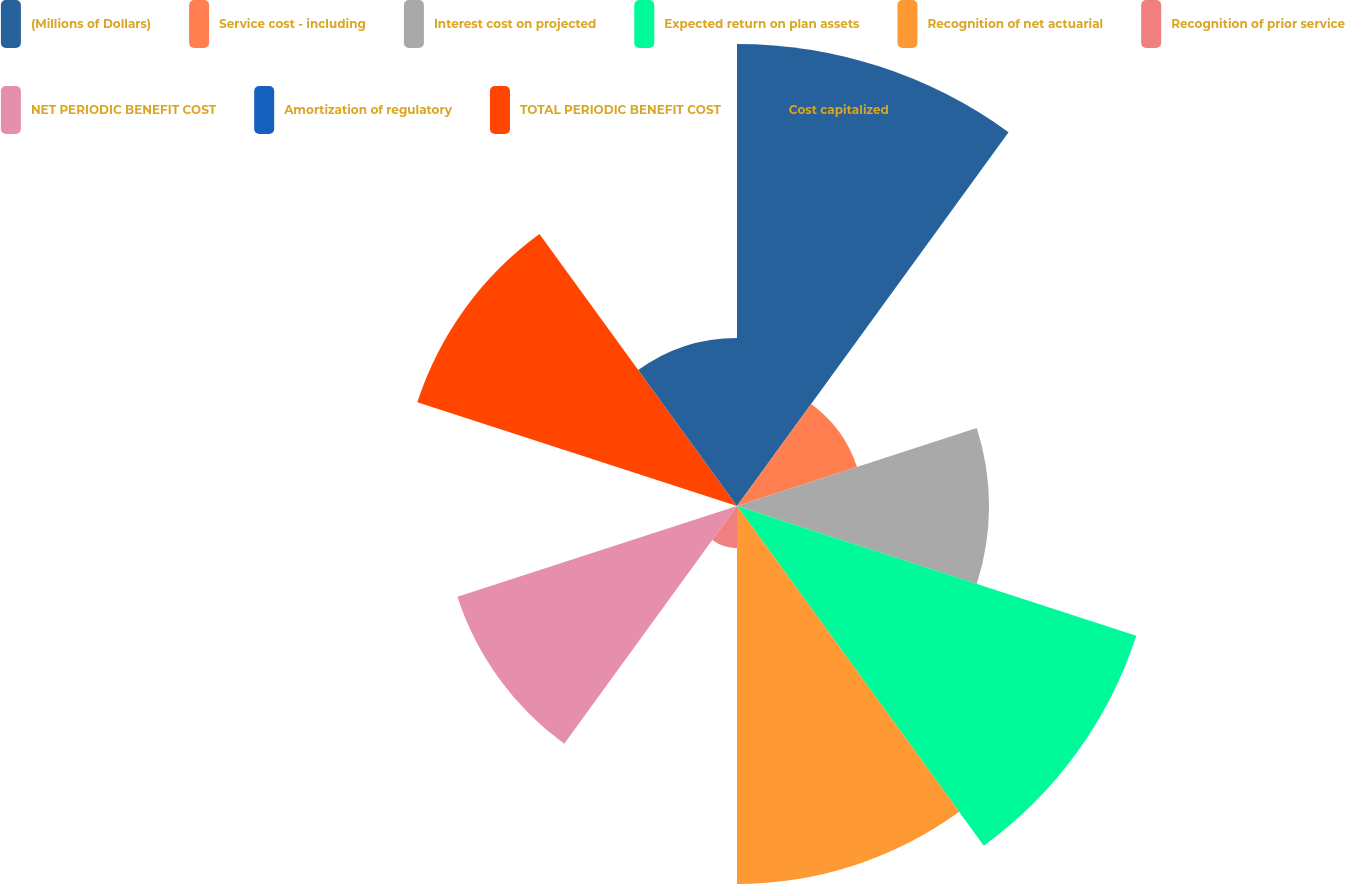Convert chart to OTSL. <chart><loc_0><loc_0><loc_500><loc_500><pie_chart><fcel>(Millions of Dollars)<fcel>Service cost - including<fcel>Interest cost on projected<fcel>Expected return on plan assets<fcel>Recognition of net actuarial<fcel>Recognition of prior service<fcel>NET PERIODIC BENEFIT COST<fcel>Amortization of regulatory<fcel>TOTAL PERIODIC BENEFIT COST<fcel>Cost capitalized<nl><fcel>18.64%<fcel>5.09%<fcel>10.17%<fcel>16.94%<fcel>15.25%<fcel>1.7%<fcel>11.86%<fcel>0.01%<fcel>13.56%<fcel>6.78%<nl></chart> 